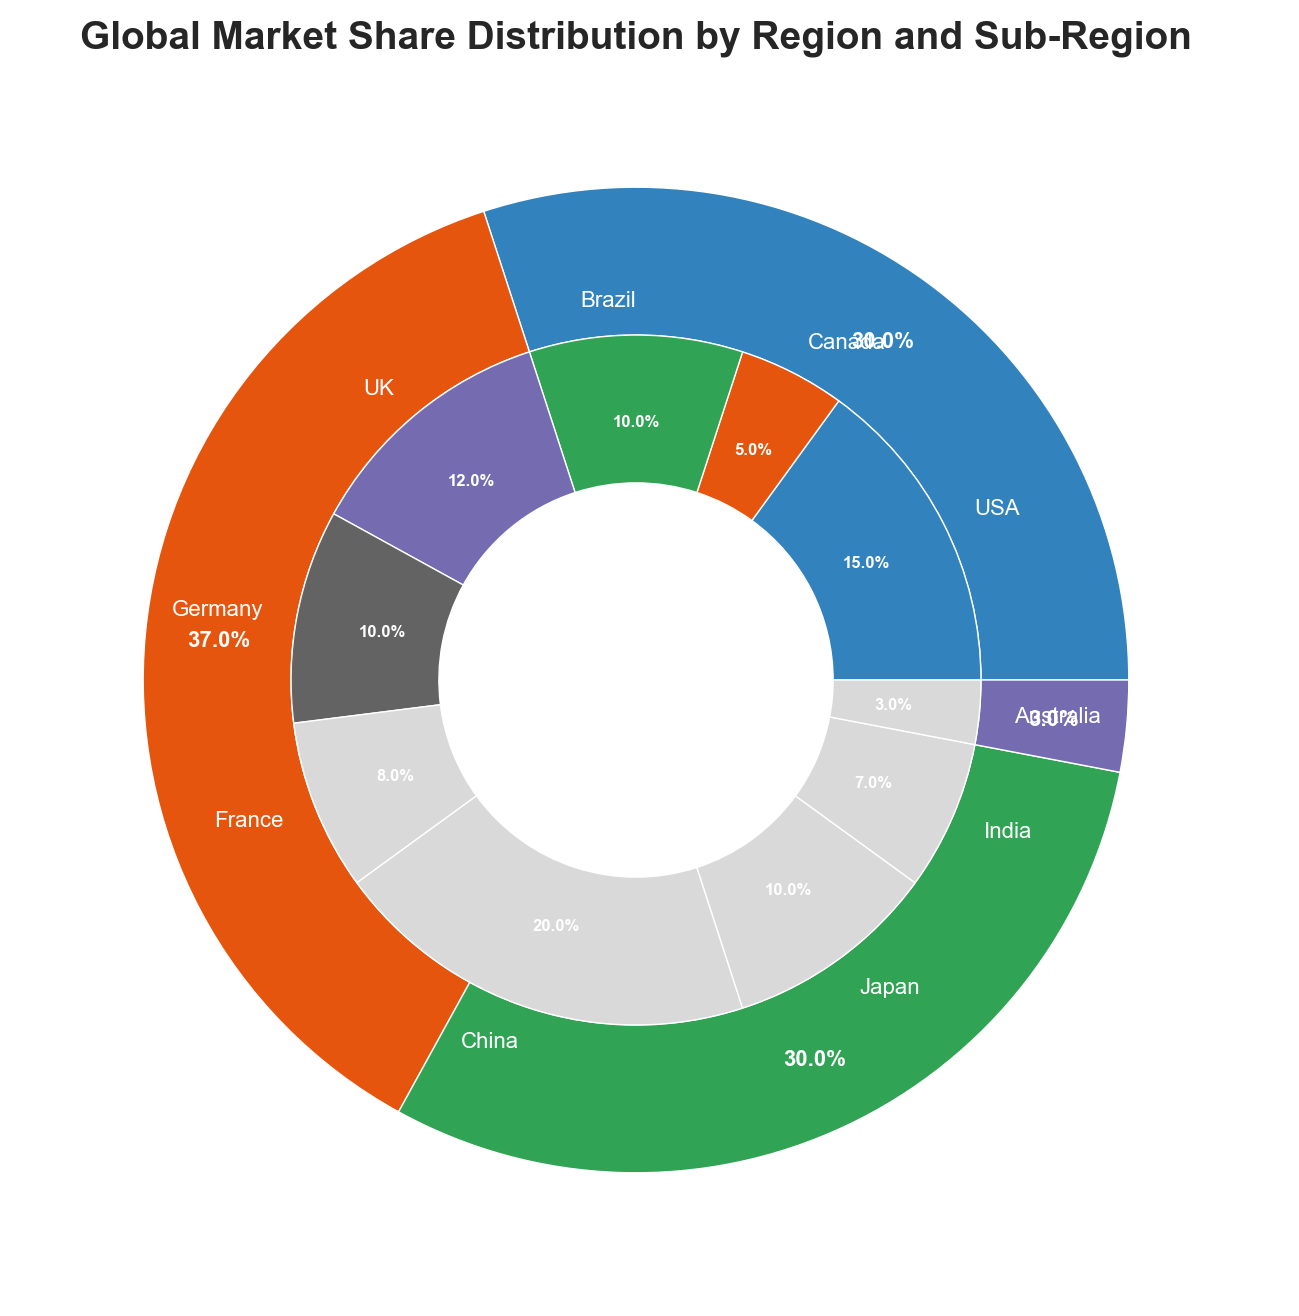What region has the highest market share? By looking at the outer ring of the pie chart, the segment labeled 'Asia' has the largest visible area. The percentage is indicated to be 37%.
Answer: Asia Which sub-region has the smallest market share? By observing the inner ring of the pie chart, 'Australia' is the smallest segment in terms of both visual area and percentage, labeled as 3%.
Answer: Australia What is the combined market share of the European countries? Summing up the market shares of the sub-regions under 'Europe' which are 'UK' (12%), 'Germany' (10%), and 'France' (8%) results in 12 + 10 + 8 = 30%.
Answer: 30% Between USA and China, which has a higher market share and by how much? Comparing the inner segments labeled 'USA' (15%) and 'China' (20%), China has a higher market share. The difference is calculated as 20 - 15 = 5%.
Answer: China by 5% How does the market share of Japan compare to Brazil? In the inner ring, 'Japan' and 'Brazil' are labeled with 10% each. Thus, their market shares are equal.
Answer: Equal Among the American sub-regions, which contributes the least to the market share? Observing the inner ring, the American sub-regions are 'USA' (15%), 'Canada' (5%), and 'Brazil' (10%). 'Canada' has the smallest share.
Answer: Canada If the combined market share of Oceania and Americas is 33%, what is the market share of Oceania? The total market share for the Americas is calculated as 15 (USA) + 5 (Canada) + 10 (Brazil) = 30%. Subtracting this from the combined market share gives 33% - 30% = 3%.
Answer: 3% What is the difference in market share between the largest and smallest regions? The largest region is 'Asia' with 37%, and the smallest is 'Oceania' with 3%. The difference is calculated as 37 - 3 = 34%.
Answer: 34% Which region has a market share closest to the global average market share of the four regions shown? There are four regions: Americas (30%), Europe (30%), Asia (37%), and Oceania (3%). The average market share can be calculated as (30 + 30 + 37 + 3) / 4 = 100 / 4 = 25%. The region closest to this average is the Americas and Europe at 30%.
Answer: Americas and Europe 